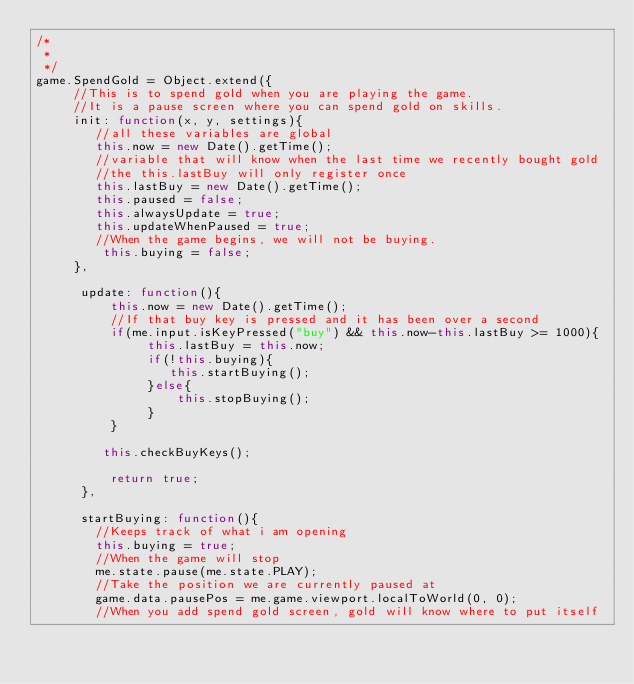<code> <loc_0><loc_0><loc_500><loc_500><_JavaScript_>/* 
 * 
 */
game.SpendGold = Object.extend({ 
     //This is to spend gold when you are playing the game. 
     //It is a pause screen where you can spend gold on skills. 
     init: function(x, y, settings){
        //all these variables are global 
        this.now = new Date().getTime();  
        //variable that will know when the last time we recently bought gold 
        //the this.lastBuy will only register once
        this.lastBuy = new Date().getTime(); 
        this.paused = false; 
        this.alwaysUpdate = true; 
        this.updateWhenPaused = true; 
        //When the game begins, we will not be buying.
         this.buying = false;
     }, 
      
      update: function(){ 
          this.now = new Date().getTime(); 
          //If that buy key is pressed and it has been over a second
          if(me.input.isKeyPressed("buy") && this.now-this.lastBuy >= 1000){
               this.lastBuy = this.now;
               if(!this.buying){
                  this.startBuying(); 
               }else{
                   this.stopBuying();
               }
          }  
           
         this.checkBuyKeys();
         
          return true;
      }, 
     
      startBuying: function(){ 
        //Keeps track of what i am opening
        this.buying = true;  
        //When the game will stop
        me.state.pause(me.state.PLAY);  
        //Take the position we are currently paused at  
        game.data.pausePos = me.game.viewport.localToWorld(0, 0); 
        //When you add spend gold screen, gold will know where to put itself</code> 